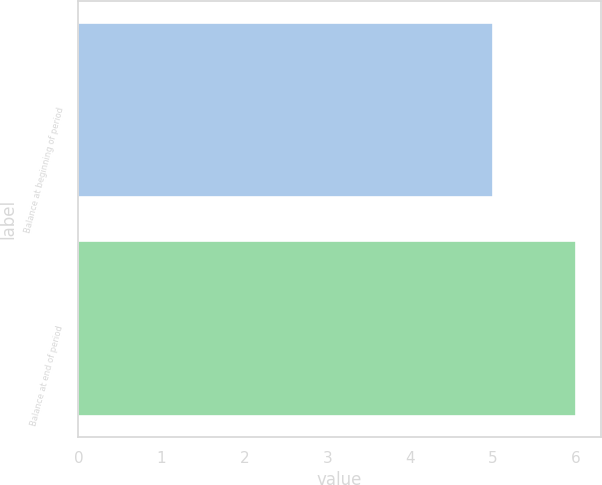Convert chart. <chart><loc_0><loc_0><loc_500><loc_500><bar_chart><fcel>Balance at beginning of period<fcel>Balance at end of period<nl><fcel>5<fcel>6<nl></chart> 